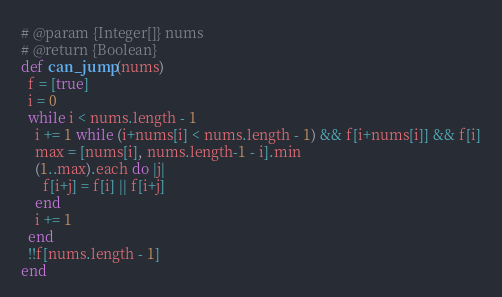Convert code to text. <code><loc_0><loc_0><loc_500><loc_500><_Ruby_># @param {Integer[]} nums
# @return {Boolean}
def can_jump(nums)
  f = [true]
  i = 0
  while i < nums.length - 1
    i += 1 while (i+nums[i] < nums.length - 1) && f[i+nums[i]] && f[i]
    max = [nums[i], nums.length-1 - i].min
    (1..max).each do |j|
      f[i+j] = f[i] || f[i+j]
    end
    i += 1
  end
  !!f[nums.length - 1]
end
</code> 